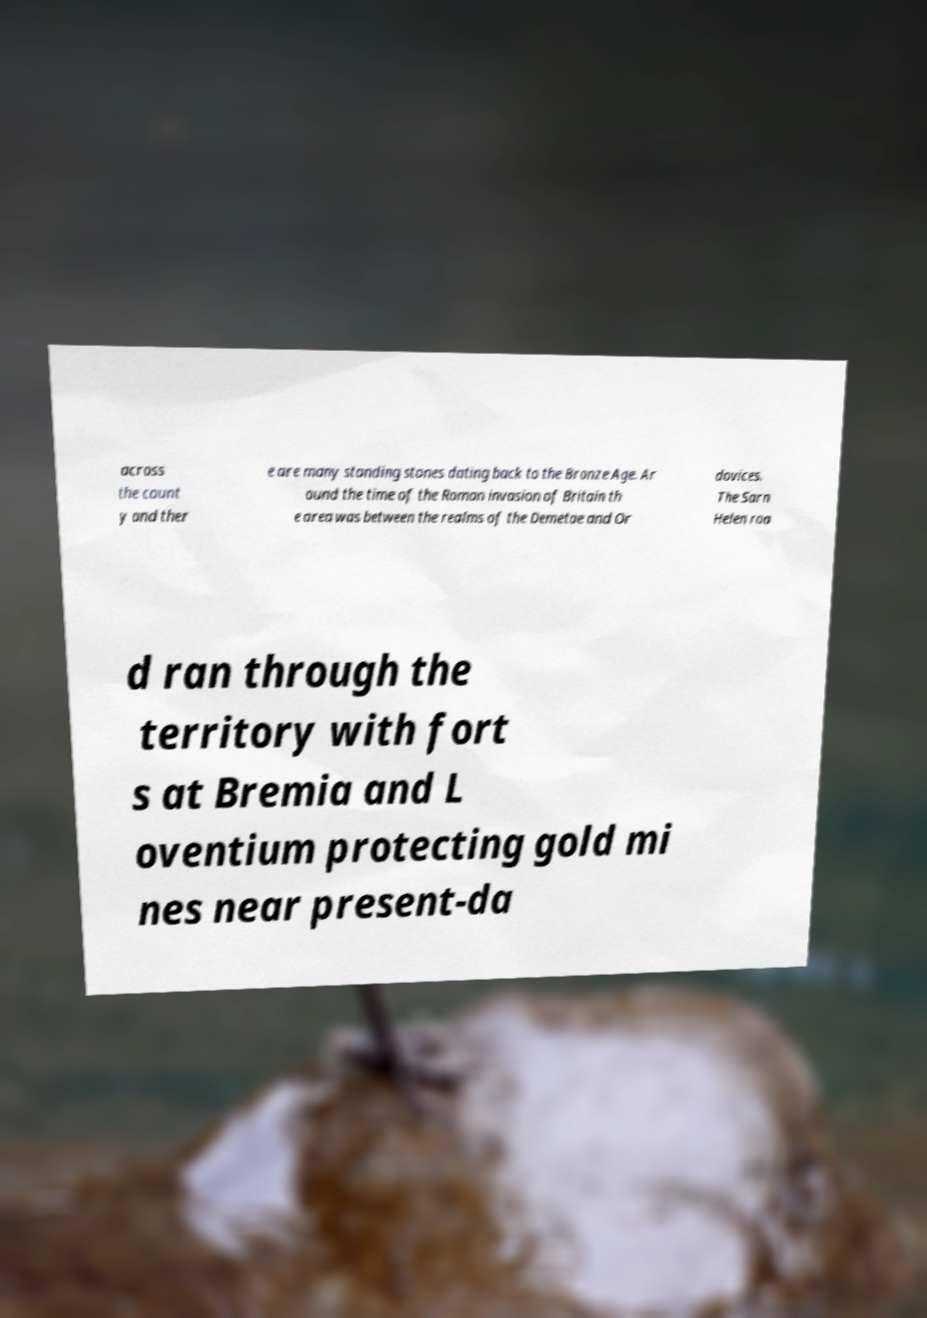Please identify and transcribe the text found in this image. across the count y and ther e are many standing stones dating back to the Bronze Age. Ar ound the time of the Roman invasion of Britain th e area was between the realms of the Demetae and Or dovices. The Sarn Helen roa d ran through the territory with fort s at Bremia and L oventium protecting gold mi nes near present-da 